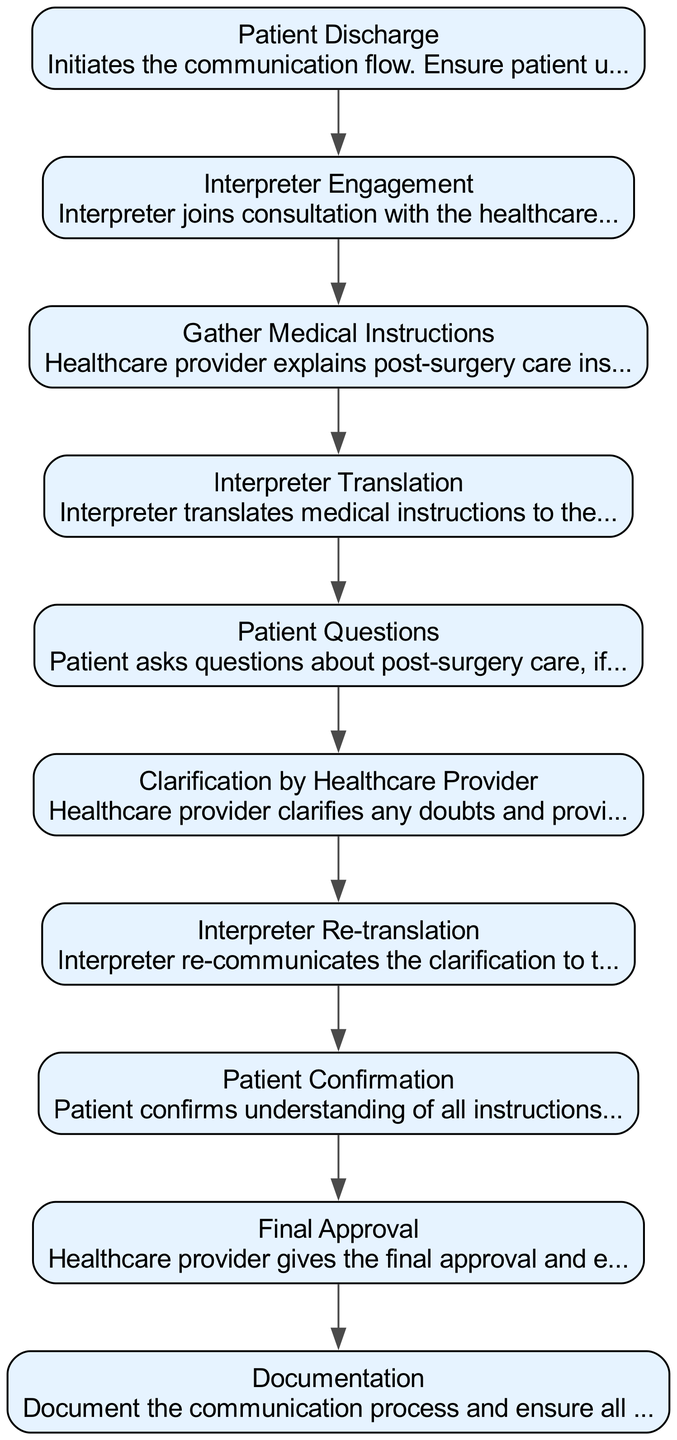What is the first element in the flowchart? The flowchart begins with "Patient Discharge," which is the initial step of the process.
Answer: Patient Discharge How many sections/nodes are in the diagram? There are 10 sections/nodes total, each representing a specific step in the communication flow for post-surgery instructions.
Answer: 10 What element follows "Interpreter Engagement"? The next element after "Interpreter Engagement" is "Gather Medical Instructions," indicating a transition from interpreter involvement to healthcare instruction.
Answer: Gather Medical Instructions What is the last element in the flowchart? The final step in the flowchart is "Documentation," which concludes the communication process and ensures all agreements are recorded.
Answer: Documentation Which element directly leads to "Patient Confirmation"? "Interpreter Re-translation" leads directly to "Patient Confirmation," showing the sequential nature of confirming understanding after re-communication.
Answer: Interpreter Re-translation What role does the interpreter play in the flowchart? The interpreter's role is to facilitate communication between the healthcare provider and the patient, ensuring that the patient comprehends medical instructions and any clarifications.
Answer: Facilitate communication Which step includes patient interactions? "Patient Questions" is the step where the patient actively engages by asking any questions they may have regarding post-surgery care.
Answer: Patient Questions How does the healthcare provider clarify uncertainties? The healthcare provider clarifies any doubts that arise during the discussion, providing additional information as needed for patient understanding.
Answer: Provides additional information What is the purpose of the "Final Approval" step? The purpose of "Final Approval" is for the healthcare provider to ensure the patient is comfortable with the post-surgery care instructions before concluding the process.
Answer: Ensure comfort with instructions 